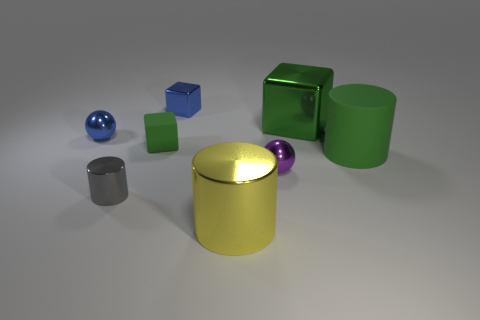Add 1 purple metallic objects. How many objects exist? 9 Subtract all cylinders. How many objects are left? 5 Subtract all tiny objects. Subtract all green rubber things. How many objects are left? 1 Add 7 green metallic things. How many green metallic things are left? 8 Add 1 purple metal objects. How many purple metal objects exist? 2 Subtract 2 green blocks. How many objects are left? 6 